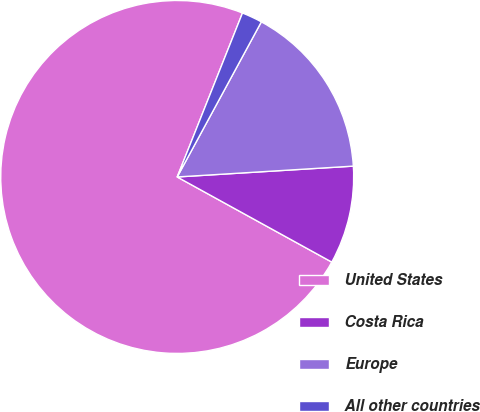<chart> <loc_0><loc_0><loc_500><loc_500><pie_chart><fcel>United States<fcel>Costa Rica<fcel>Europe<fcel>All other countries<nl><fcel>73.02%<fcel>8.99%<fcel>16.11%<fcel>1.88%<nl></chart> 